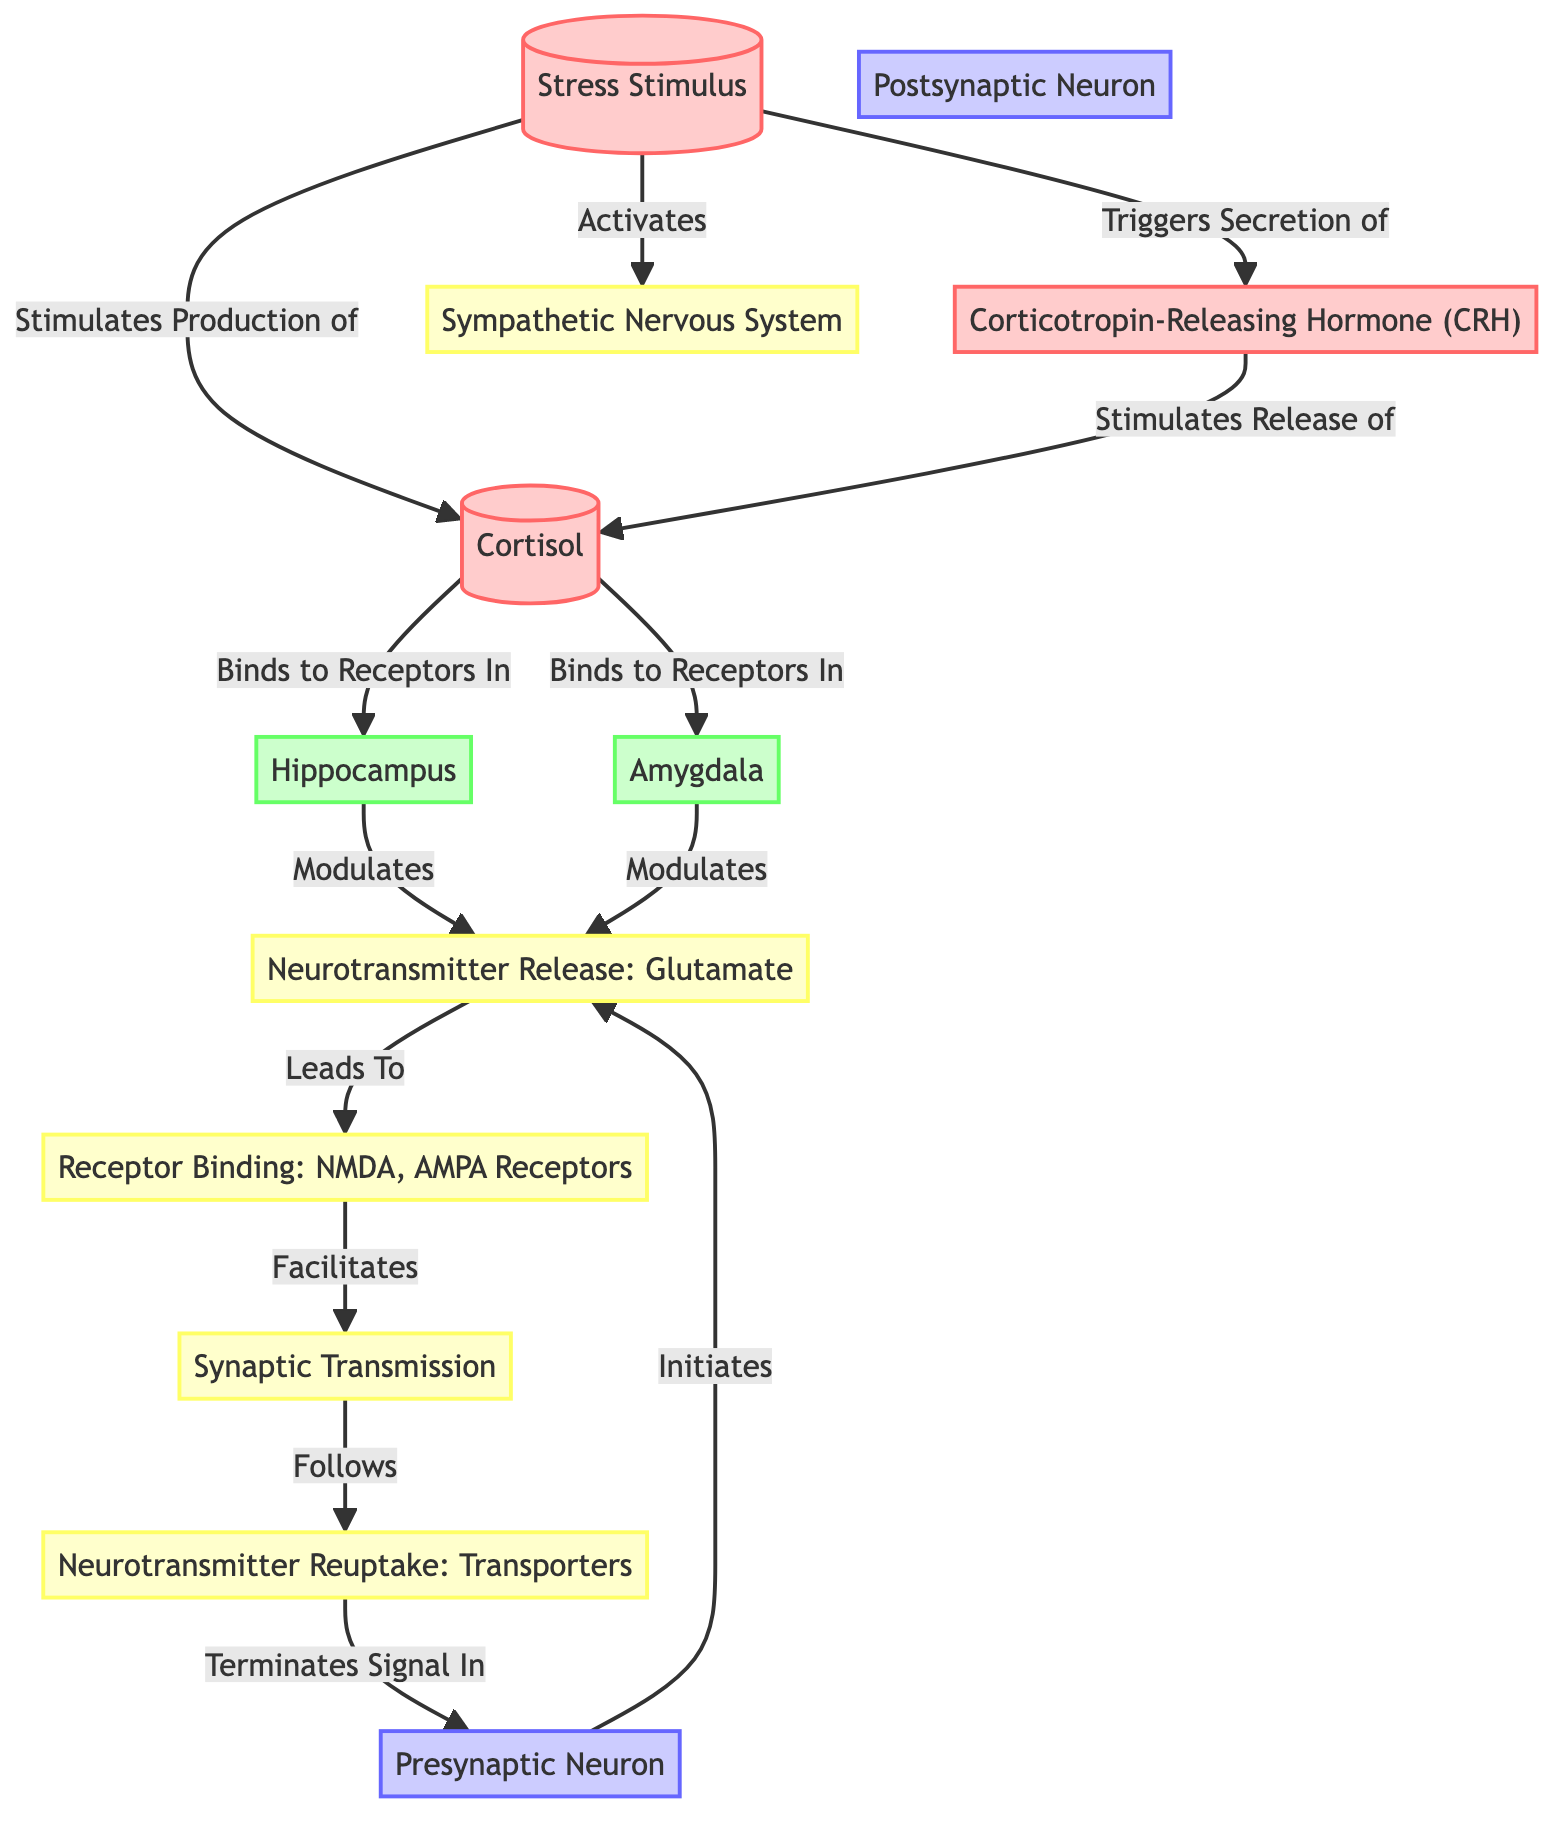What triggers the secretion of corticotropin-releasing hormone? The diagram indicates that the "Stress Stimulus" triggers the secretion of "Corticotropin-Releasing Hormone (CRH)". This connection is shown with an edge labeled "Triggers Secretion of" leading from "Stress Stimulus" to "Corticotropin-Releasing Hormone (CRH)".
Answer: Stress Stimulus Which two brain regions are influenced by cortisol? According to the diagram, cortisol binds to receptors in both "Hippocampus" and "Amygdala". This relationship is depicted with edges labeled "Binds to Receptors In" from cortisol to each brain region.
Answer: Hippocampus, Amygdala How many total nodes are there in the diagram? Counting all distinct representations for nodes in the diagram, we identify "Stress Stimulus", "Cortisol", "Hippocampus", "Amygdala", "Presynaptic Neuron", "Postsynaptic Neuron", "Neurotransmitter Release: Glutamate", "Receptor Binding: NMDA, AMPA Receptors", "Synaptic Transmission", "Neurotransmitter Reuptake: Transporters", and "Corticotropin-Releasing Hormone (CRH)", yielding a total of 11 nodes.
Answer: 11 What is released by the presynaptic neuron? The diagram specifies that the "Presynaptic Neuron" initiates the process of "Neurotransmitter Release: Glutamate". This is indicated with an edge labeled "Initiates" leading to "Neurotransmitter Release: Glutamate".
Answer: Neurotransmitter Release: Glutamate What process follows synaptic transmission? In the flowchart, "Neurotransmitter Reuptake: Transporters" directly follows "Synaptic Transmission", as depicted by the edge labeled "Follows". This shows that neurotransmitter reuptake occurs after synaptic transmission.
Answer: Neurotransmitter Reuptake: Transporters What does corticotropin-releasing hormone stimulate? The flowchart indicates that "Corticotropin-Releasing Hormone (CRH)" stimulates the release of "Cortisol", demonstrated by the edge labeled "Stimulates Release of". This shows the regulatory relationship in the pathway.
Answer: Cortisol Which receptors are involved in receptor binding according to the diagram? The diagram specifies that the receptor binding involves "NMDA" and "AMPA Receptors", as shown in the node labeled "Receptor Binding: NMDA, AMPA Receptors". This indicates the specificity of receptors for neurotransmitter interaction.
Answer: NMDA, AMPA Receptors What is the role of the sympathetic nervous system in response to stress? The diagram outlines that the sympathetic nervous system is activated as a result of the "Stress Stimulus". This connection is illustrated by the edge labeled "Activates". Thus, it plays a role in the physiological response to stress.
Answer: Activated 